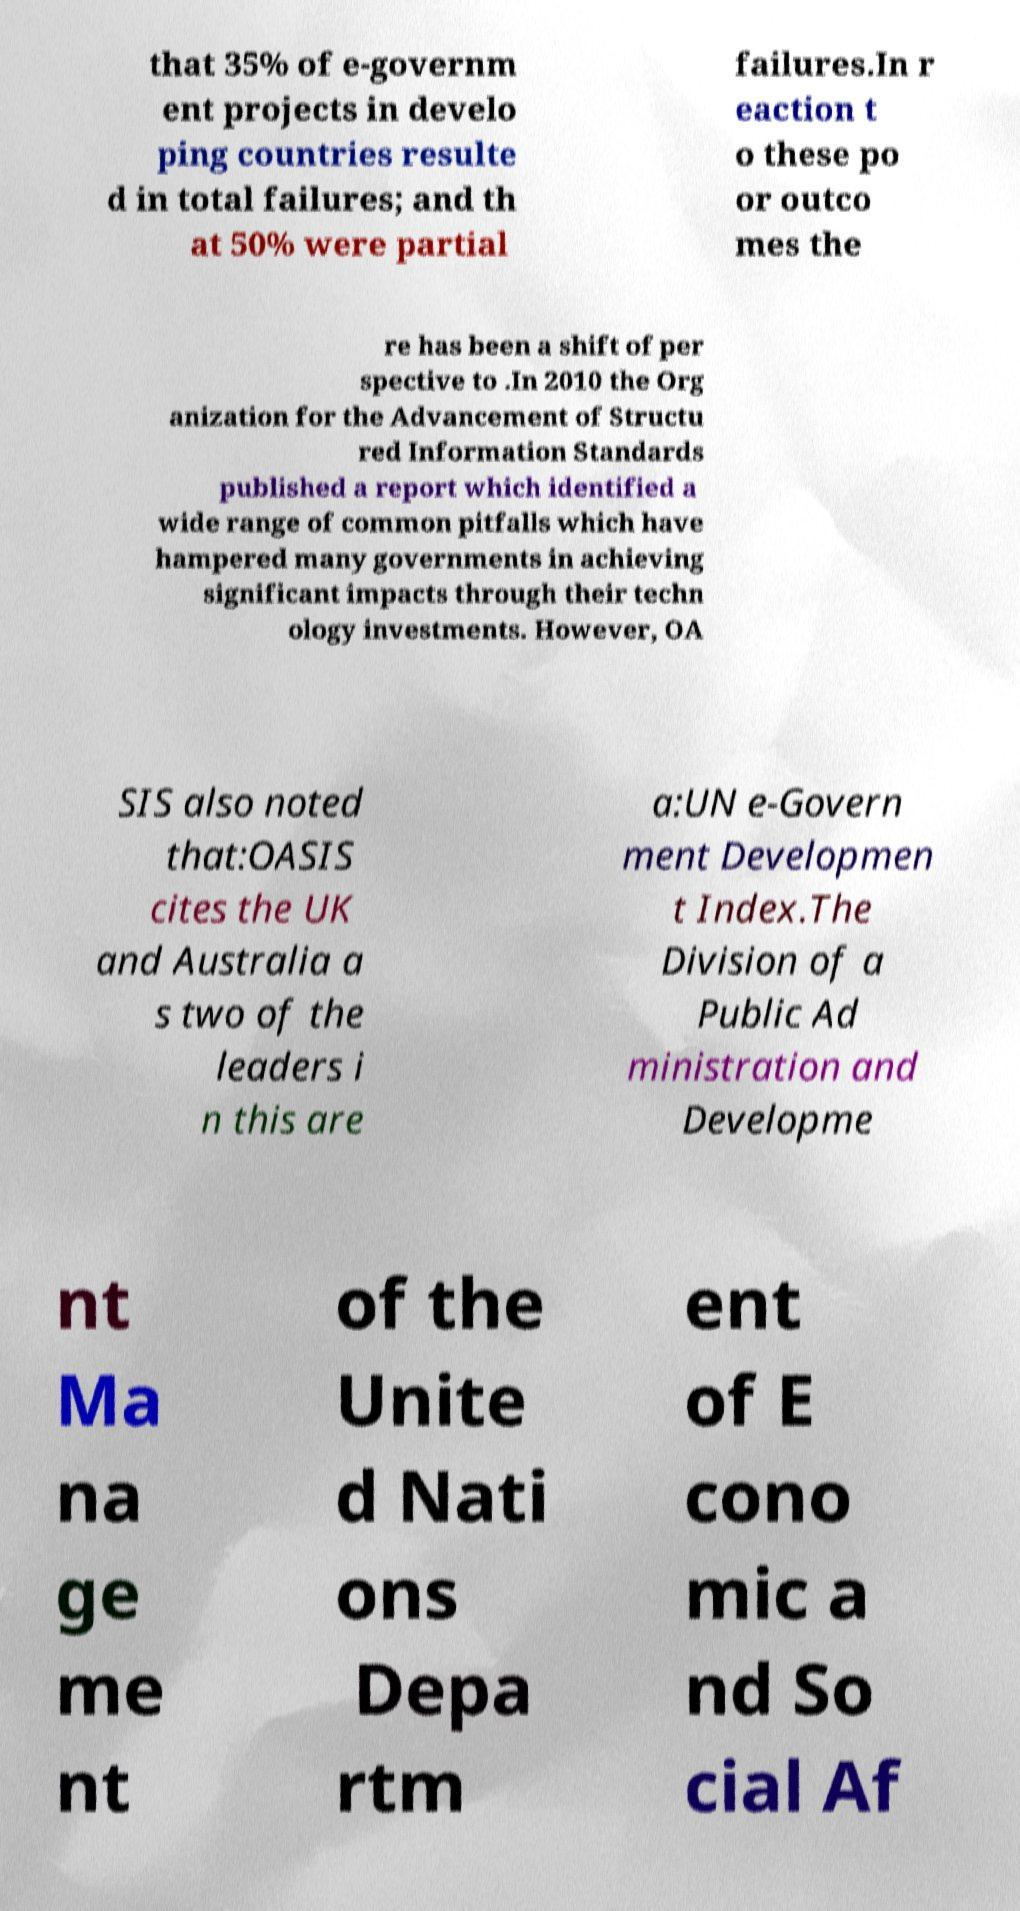Could you extract and type out the text from this image? that 35% of e-governm ent projects in develo ping countries resulte d in total failures; and th at 50% were partial failures.In r eaction t o these po or outco mes the re has been a shift of per spective to .In 2010 the Org anization for the Advancement of Structu red Information Standards published a report which identified a wide range of common pitfalls which have hampered many governments in achieving significant impacts through their techn ology investments. However, OA SIS also noted that:OASIS cites the UK and Australia a s two of the leaders i n this are a:UN e-Govern ment Developmen t Index.The Division of a Public Ad ministration and Developme nt Ma na ge me nt of the Unite d Nati ons Depa rtm ent of E cono mic a nd So cial Af 